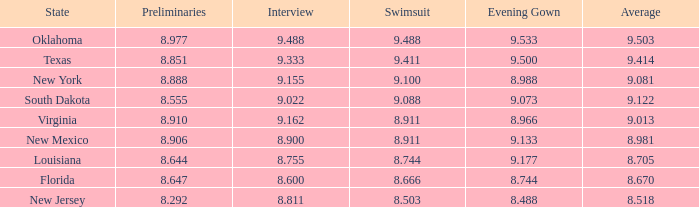What is the total number of average where evening gown is 8.988 1.0. 